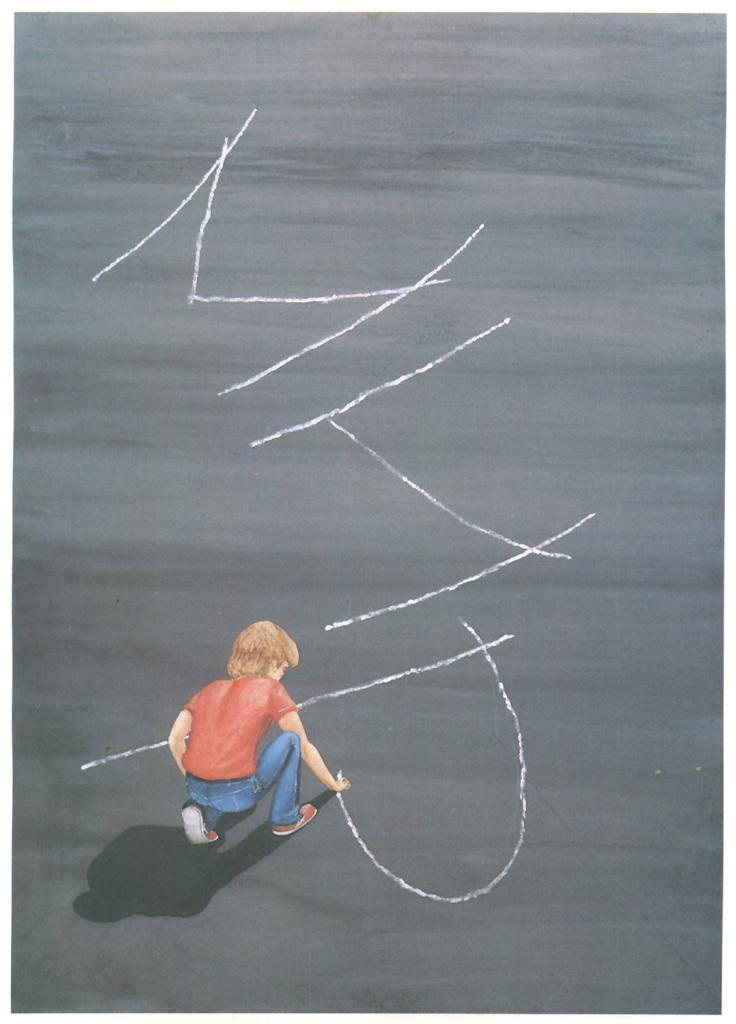What is the main subject of the image? There is a drawing in the image. What does the drawing depict? The drawing depicts a person. What is the person in the drawing doing? The person is writing on a surface in the drawing. How many sisters are present in the drawing? There are no sisters mentioned or depicted in the drawing; it only shows a person writing on a surface. 